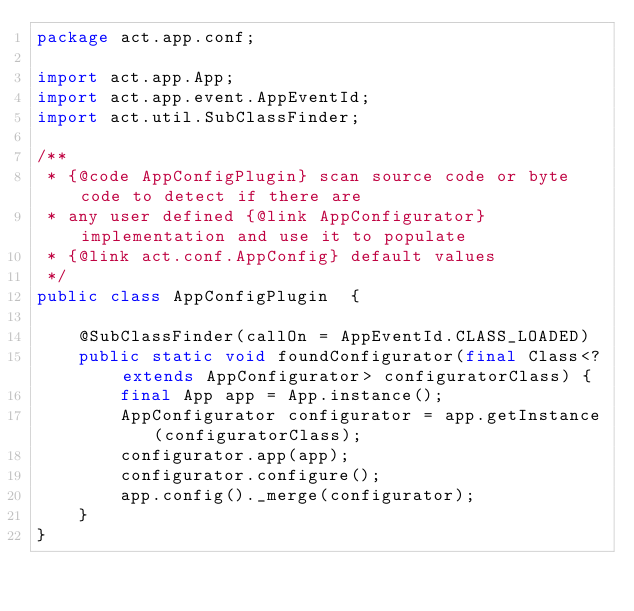Convert code to text. <code><loc_0><loc_0><loc_500><loc_500><_Java_>package act.app.conf;

import act.app.App;
import act.app.event.AppEventId;
import act.util.SubClassFinder;

/**
 * {@code AppConfigPlugin} scan source code or byte code to detect if there are
 * any user defined {@link AppConfigurator} implementation and use it to populate
 * {@link act.conf.AppConfig} default values
 */
public class AppConfigPlugin  {

    @SubClassFinder(callOn = AppEventId.CLASS_LOADED)
    public static void foundConfigurator(final Class<? extends AppConfigurator> configuratorClass) {
        final App app = App.instance();
        AppConfigurator configurator = app.getInstance(configuratorClass);
        configurator.app(app);
        configurator.configure();
        app.config()._merge(configurator);
    }
}</code> 